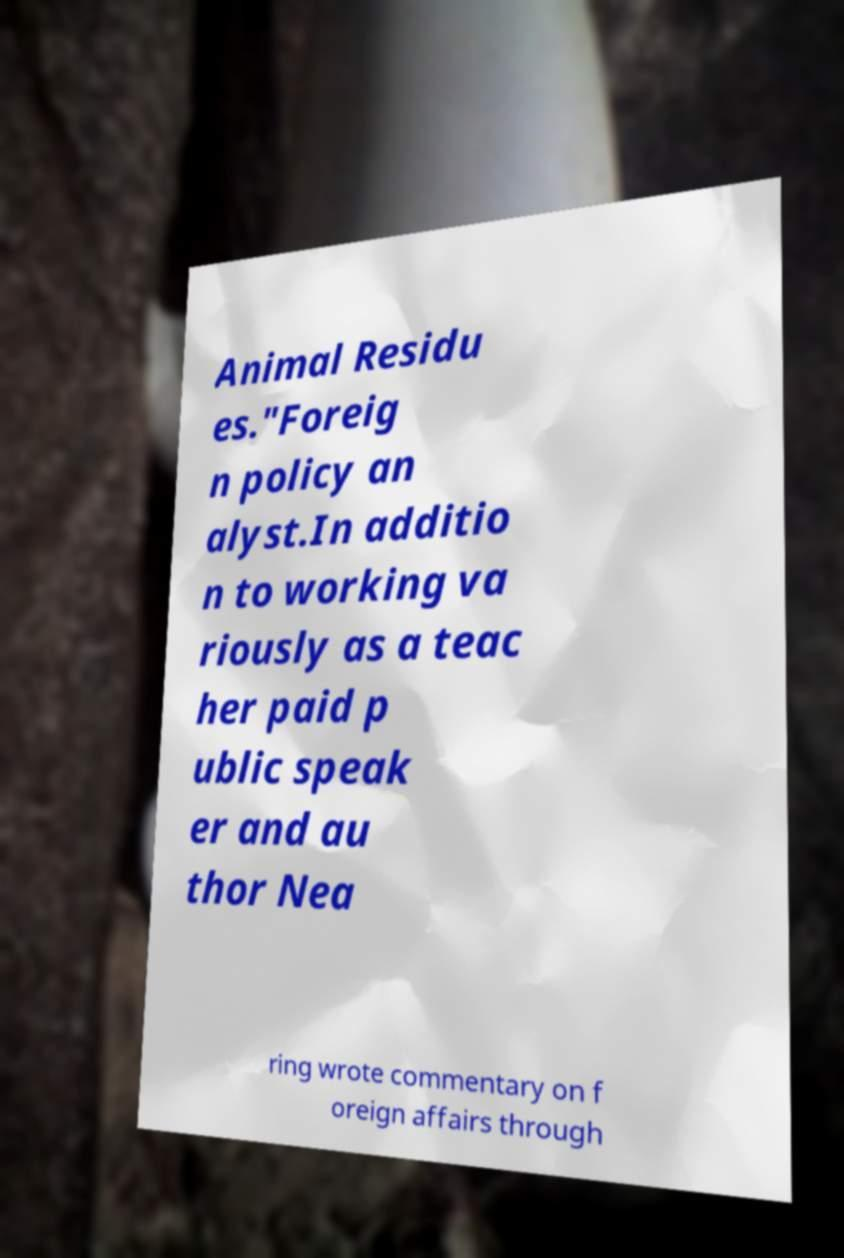What messages or text are displayed in this image? I need them in a readable, typed format. Animal Residu es."Foreig n policy an alyst.In additio n to working va riously as a teac her paid p ublic speak er and au thor Nea ring wrote commentary on f oreign affairs through 